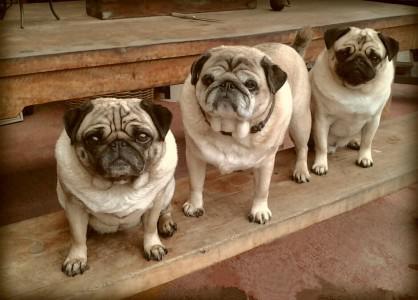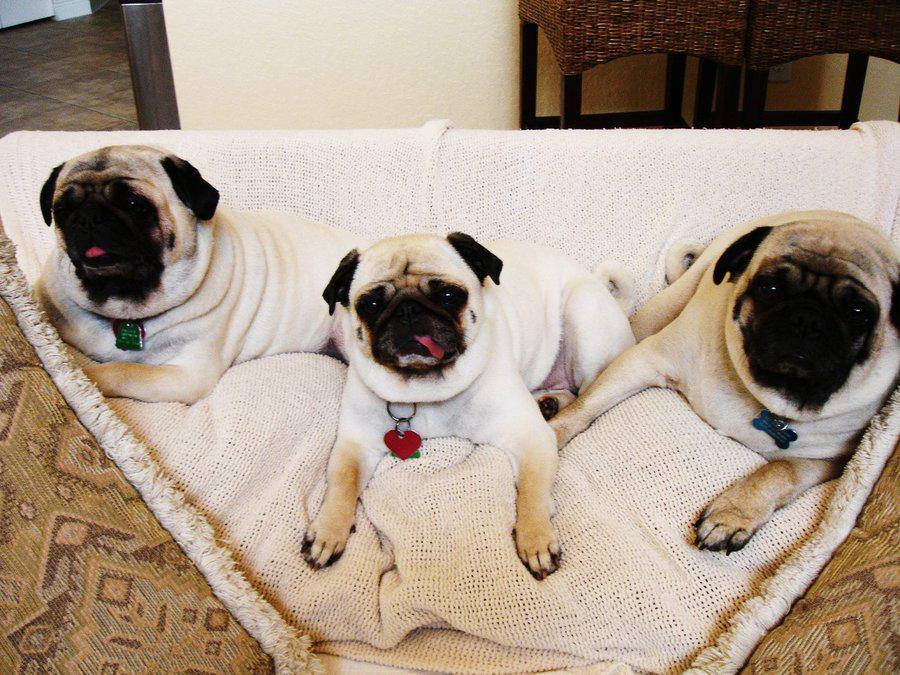The first image is the image on the left, the second image is the image on the right. For the images shown, is this caption "An image contains three pug dogs on a wooden picnic table." true? Answer yes or no. Yes. The first image is the image on the left, the second image is the image on the right. Assess this claim about the two images: "Three dogs are on a wooden step in one of the images.". Correct or not? Answer yes or no. Yes. 